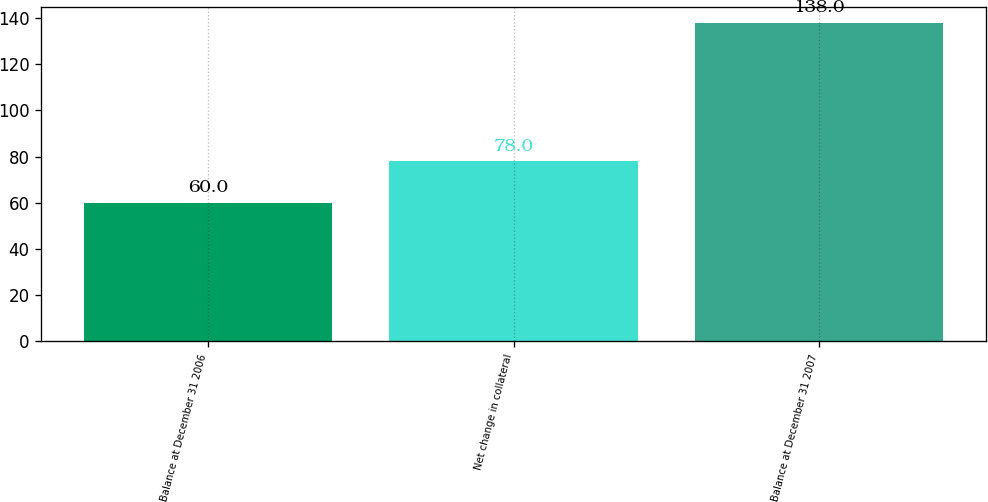<chart> <loc_0><loc_0><loc_500><loc_500><bar_chart><fcel>Balance at December 31 2006<fcel>Net change in collateral<fcel>Balance at December 31 2007<nl><fcel>60<fcel>78<fcel>138<nl></chart> 